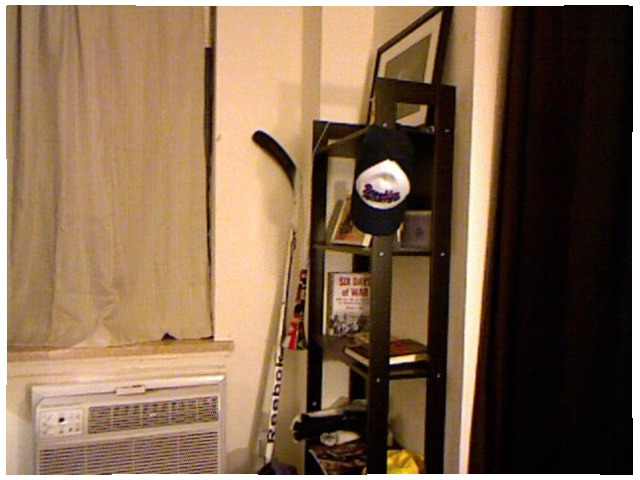<image>
Is there a hockey stick in front of the wall? Yes. The hockey stick is positioned in front of the wall, appearing closer to the camera viewpoint. Is there a hat next to the shelf? Yes. The hat is positioned adjacent to the shelf, located nearby in the same general area. 